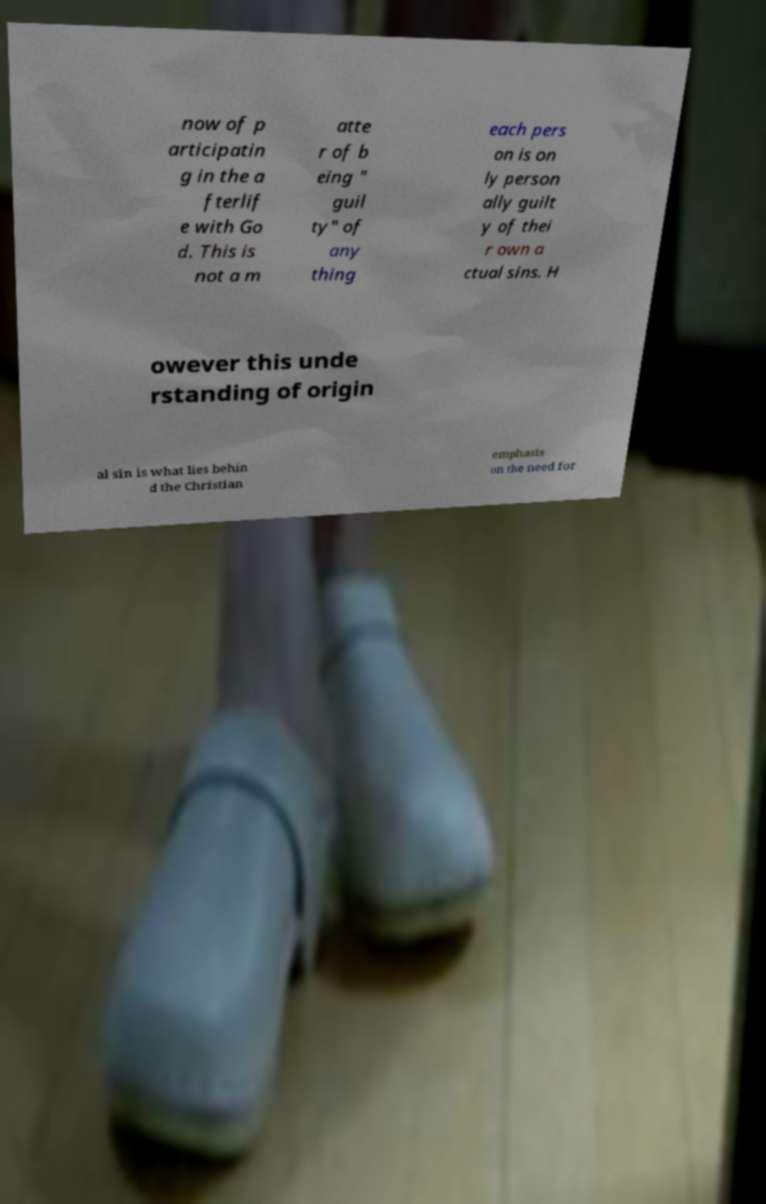Please identify and transcribe the text found in this image. now of p articipatin g in the a fterlif e with Go d. This is not a m atte r of b eing " guil ty" of any thing each pers on is on ly person ally guilt y of thei r own a ctual sins. H owever this unde rstanding of origin al sin is what lies behin d the Christian emphasis on the need for 